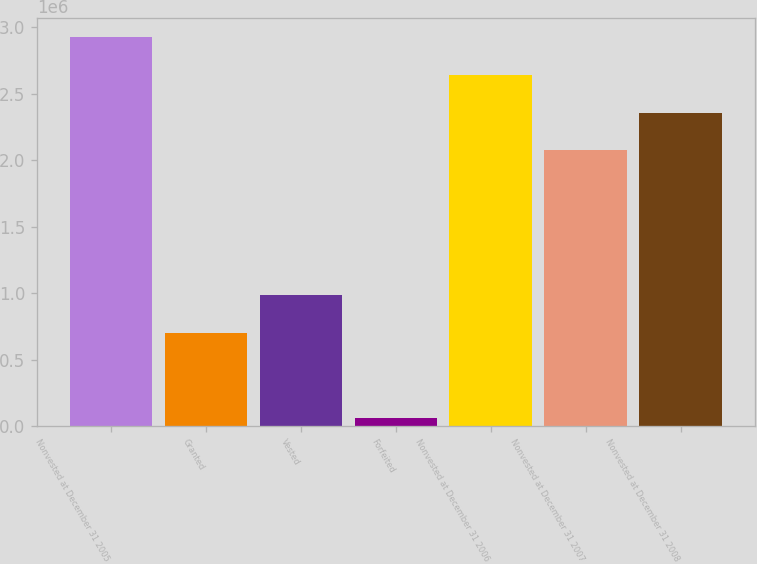<chart> <loc_0><loc_0><loc_500><loc_500><bar_chart><fcel>Nonvested at December 31 2005<fcel>Granted<fcel>Vested<fcel>Forfeited<fcel>Nonvested at December 31 2006<fcel>Nonvested at December 31 2007<fcel>Nonvested at December 31 2008<nl><fcel>2.92417e+06<fcel>700592<fcel>987200<fcel>58812<fcel>2.64099e+06<fcel>2.07464e+06<fcel>2.35781e+06<nl></chart> 